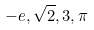Convert formula to latex. <formula><loc_0><loc_0><loc_500><loc_500>- e , \sqrt { 2 } , 3 , \pi</formula> 